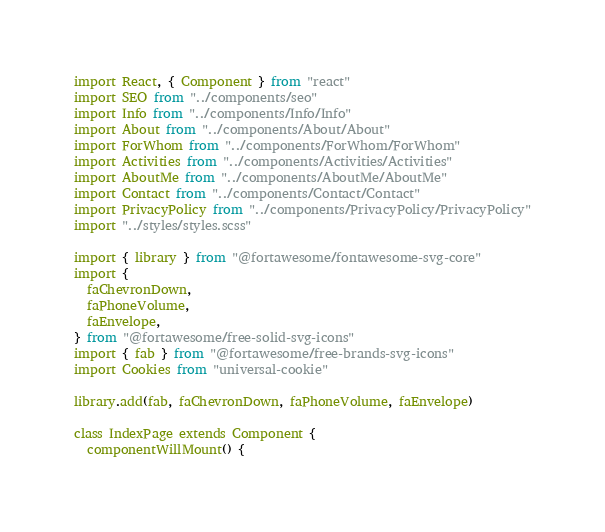Convert code to text. <code><loc_0><loc_0><loc_500><loc_500><_JavaScript_>import React, { Component } from "react"
import SEO from "../components/seo"
import Info from "../components/Info/Info"
import About from "../components/About/About"
import ForWhom from "../components/ForWhom/ForWhom"
import Activities from "../components/Activities/Activities"
import AboutMe from "../components/AboutMe/AboutMe"
import Contact from "../components/Contact/Contact"
import PrivacyPolicy from "../components/PrivacyPolicy/PrivacyPolicy"
import "../styles/styles.scss"

import { library } from "@fortawesome/fontawesome-svg-core"
import {
  faChevronDown,
  faPhoneVolume,
  faEnvelope,
} from "@fortawesome/free-solid-svg-icons"
import { fab } from "@fortawesome/free-brands-svg-icons"
import Cookies from "universal-cookie"

library.add(fab, faChevronDown, faPhoneVolume, faEnvelope)

class IndexPage extends Component {
  componentWillMount() {</code> 